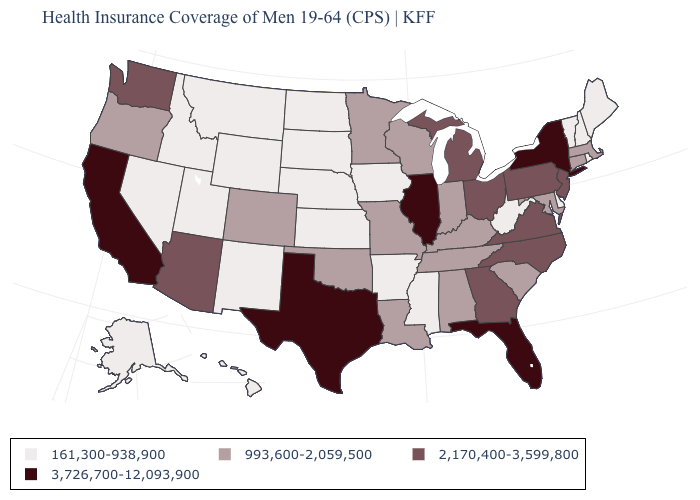Name the states that have a value in the range 993,600-2,059,500?
Write a very short answer. Alabama, Colorado, Connecticut, Indiana, Kentucky, Louisiana, Maryland, Massachusetts, Minnesota, Missouri, Oklahoma, Oregon, South Carolina, Tennessee, Wisconsin. What is the value of Florida?
Be succinct. 3,726,700-12,093,900. What is the value of Connecticut?
Give a very brief answer. 993,600-2,059,500. Does Pennsylvania have the lowest value in the USA?
Quick response, please. No. What is the value of Iowa?
Concise answer only. 161,300-938,900. Name the states that have a value in the range 993,600-2,059,500?
Be succinct. Alabama, Colorado, Connecticut, Indiana, Kentucky, Louisiana, Maryland, Massachusetts, Minnesota, Missouri, Oklahoma, Oregon, South Carolina, Tennessee, Wisconsin. Which states have the lowest value in the Northeast?
Concise answer only. Maine, New Hampshire, Rhode Island, Vermont. Does Nevada have the lowest value in the West?
Quick response, please. Yes. Does Georgia have the highest value in the USA?
Be succinct. No. Which states have the lowest value in the USA?
Answer briefly. Alaska, Arkansas, Delaware, Hawaii, Idaho, Iowa, Kansas, Maine, Mississippi, Montana, Nebraska, Nevada, New Hampshire, New Mexico, North Dakota, Rhode Island, South Dakota, Utah, Vermont, West Virginia, Wyoming. What is the value of California?
Quick response, please. 3,726,700-12,093,900. What is the lowest value in the USA?
Answer briefly. 161,300-938,900. Name the states that have a value in the range 2,170,400-3,599,800?
Short answer required. Arizona, Georgia, Michigan, New Jersey, North Carolina, Ohio, Pennsylvania, Virginia, Washington. What is the highest value in the West ?
Give a very brief answer. 3,726,700-12,093,900. Name the states that have a value in the range 3,726,700-12,093,900?
Give a very brief answer. California, Florida, Illinois, New York, Texas. 